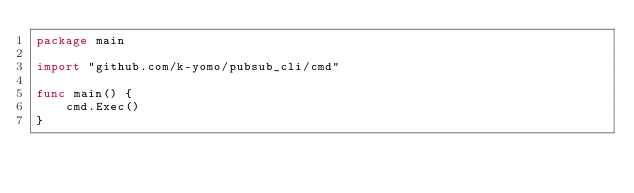Convert code to text. <code><loc_0><loc_0><loc_500><loc_500><_Go_>package main

import "github.com/k-yomo/pubsub_cli/cmd"

func main() {
	cmd.Exec()
}
</code> 